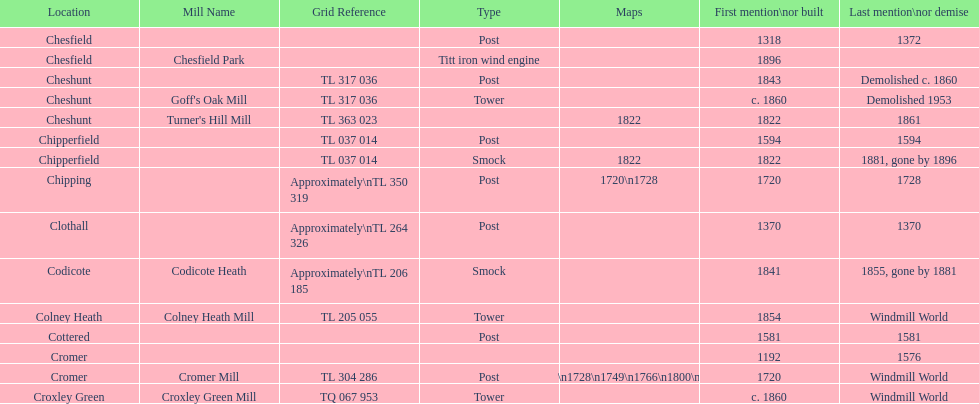What is the number of mills first mentioned or built in the 1800s? 8. Help me parse the entirety of this table. {'header': ['Location', 'Mill Name', 'Grid Reference', 'Type', 'Maps', 'First mention\\nor built', 'Last mention\\nor demise'], 'rows': [['Chesfield', '', '', 'Post', '', '1318', '1372'], ['Chesfield', 'Chesfield Park', '', 'Titt iron wind engine', '', '1896', ''], ['Cheshunt', '', 'TL 317 036', 'Post', '', '1843', 'Demolished c. 1860'], ['Cheshunt', "Goff's Oak Mill", 'TL 317 036', 'Tower', '', 'c. 1860', 'Demolished 1953'], ['Cheshunt', "Turner's Hill Mill", 'TL 363 023', '', '1822', '1822', '1861'], ['Chipperfield', '', 'TL 037 014', 'Post', '', '1594', '1594'], ['Chipperfield', '', 'TL 037 014', 'Smock', '1822', '1822', '1881, gone by 1896'], ['Chipping', '', 'Approximately\\nTL 350 319', 'Post', '1720\\n1728', '1720', '1728'], ['Clothall', '', 'Approximately\\nTL 264 326', 'Post', '', '1370', '1370'], ['Codicote', 'Codicote Heath', 'Approximately\\nTL 206 185', 'Smock', '', '1841', '1855, gone by 1881'], ['Colney Heath', 'Colney Heath Mill', 'TL 205 055', 'Tower', '', '1854', 'Windmill World'], ['Cottered', '', '', 'Post', '', '1581', '1581'], ['Cromer', '', '', '', '', '1192', '1576'], ['Cromer', 'Cromer Mill', 'TL 304 286', 'Post', '1720\\n1728\\n1749\\n1766\\n1800\\n1822', '1720', 'Windmill World'], ['Croxley Green', 'Croxley Green Mill', 'TQ 067 953', 'Tower', '', 'c. 1860', 'Windmill World']]} 